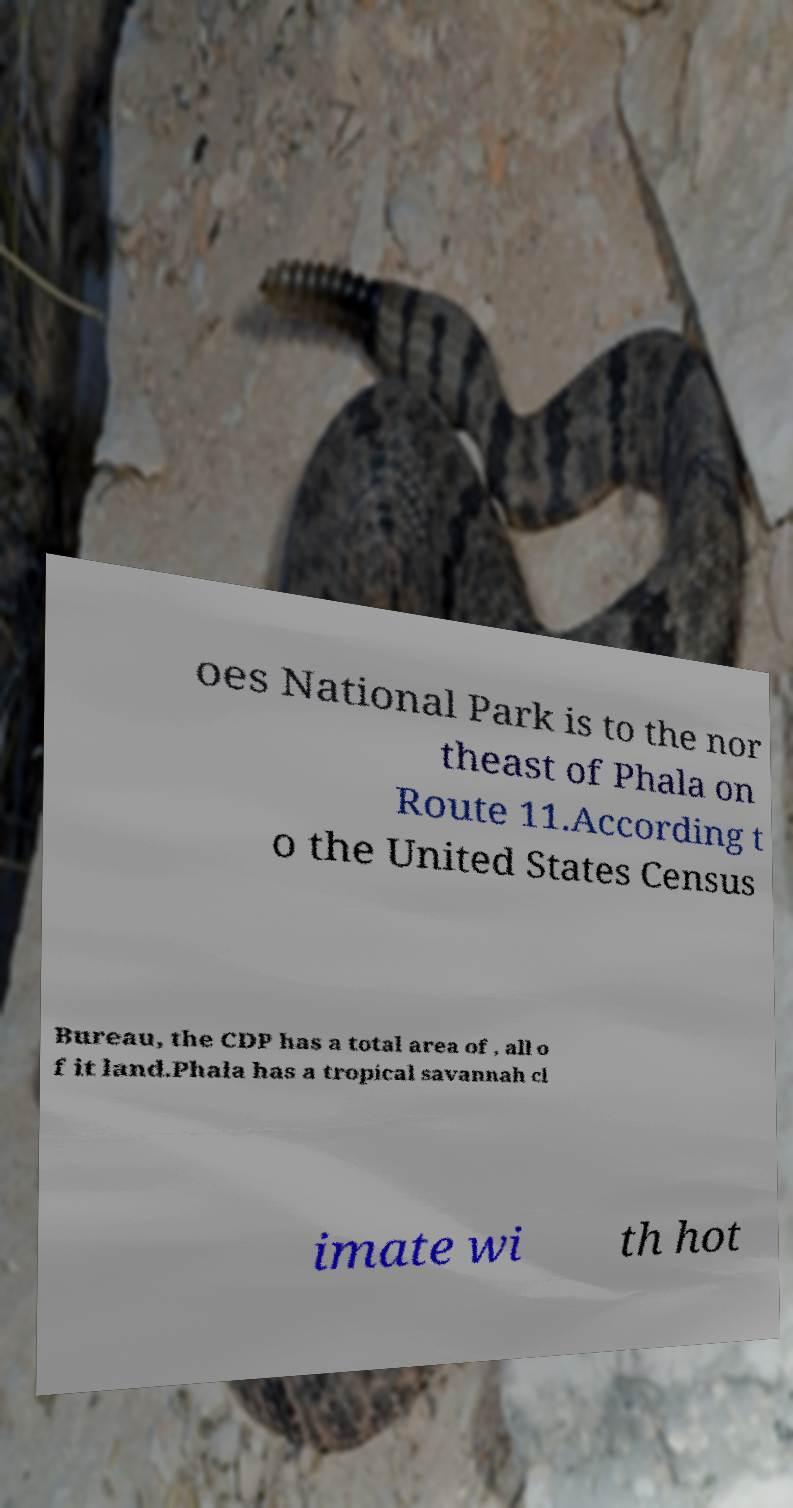What messages or text are displayed in this image? I need them in a readable, typed format. oes National Park is to the nor theast of Phala on Route 11.According t o the United States Census Bureau, the CDP has a total area of , all o f it land.Phala has a tropical savannah cl imate wi th hot 